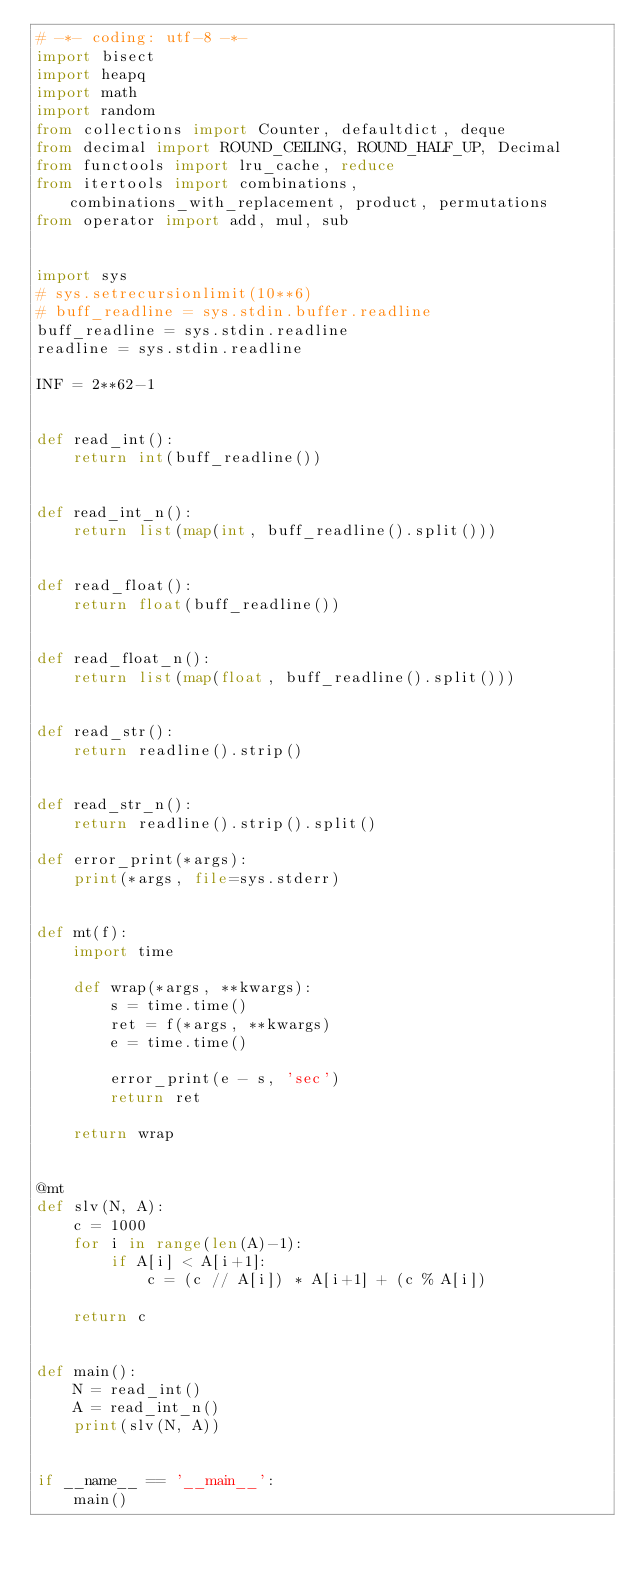Convert code to text. <code><loc_0><loc_0><loc_500><loc_500><_Python_># -*- coding: utf-8 -*-
import bisect
import heapq
import math
import random
from collections import Counter, defaultdict, deque
from decimal import ROUND_CEILING, ROUND_HALF_UP, Decimal
from functools import lru_cache, reduce
from itertools import combinations, combinations_with_replacement, product, permutations
from operator import add, mul, sub


import sys
# sys.setrecursionlimit(10**6)
# buff_readline = sys.stdin.buffer.readline
buff_readline = sys.stdin.readline
readline = sys.stdin.readline

INF = 2**62-1


def read_int():
    return int(buff_readline())


def read_int_n():
    return list(map(int, buff_readline().split()))


def read_float():
    return float(buff_readline())


def read_float_n():
    return list(map(float, buff_readline().split()))


def read_str():
    return readline().strip()


def read_str_n():
    return readline().strip().split()

def error_print(*args):
    print(*args, file=sys.stderr)


def mt(f):
    import time

    def wrap(*args, **kwargs):
        s = time.time()
        ret = f(*args, **kwargs)
        e = time.time()

        error_print(e - s, 'sec')
        return ret

    return wrap


@mt
def slv(N, A):
    c = 1000
    for i in range(len(A)-1):
        if A[i] < A[i+1]:
            c = (c // A[i]) * A[i+1] + (c % A[i])

    return c


def main():
    N = read_int()
    A = read_int_n()
    print(slv(N, A))


if __name__ == '__main__':
    main()
</code> 